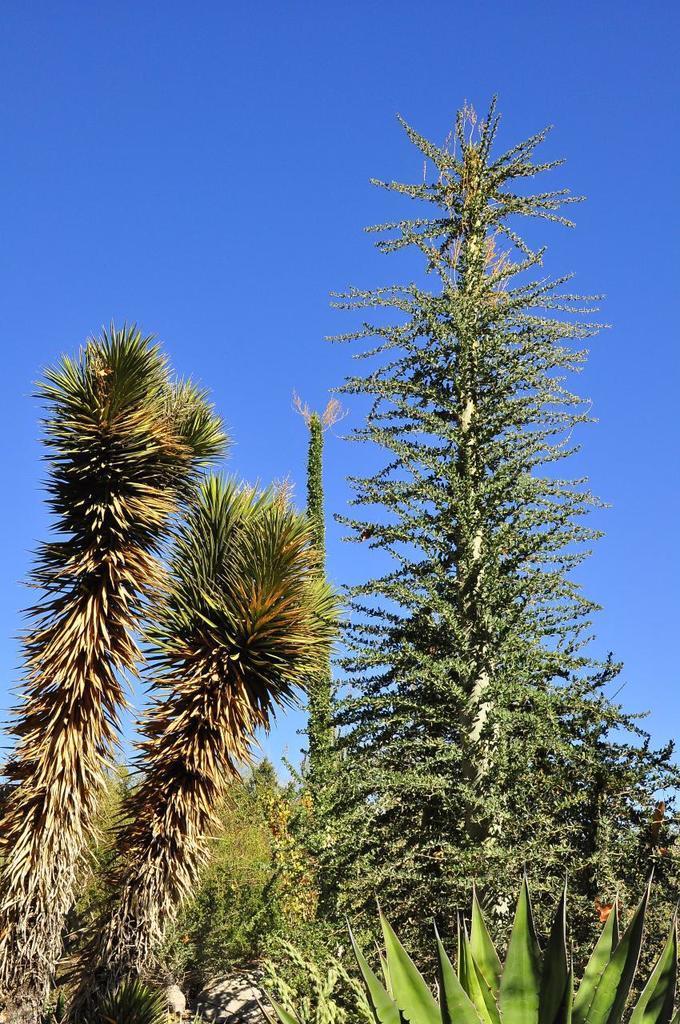Could you give a brief overview of what you see in this image? At the bottom of this image, there are plants and trees. In the background, there are clouds in the blue sky. 